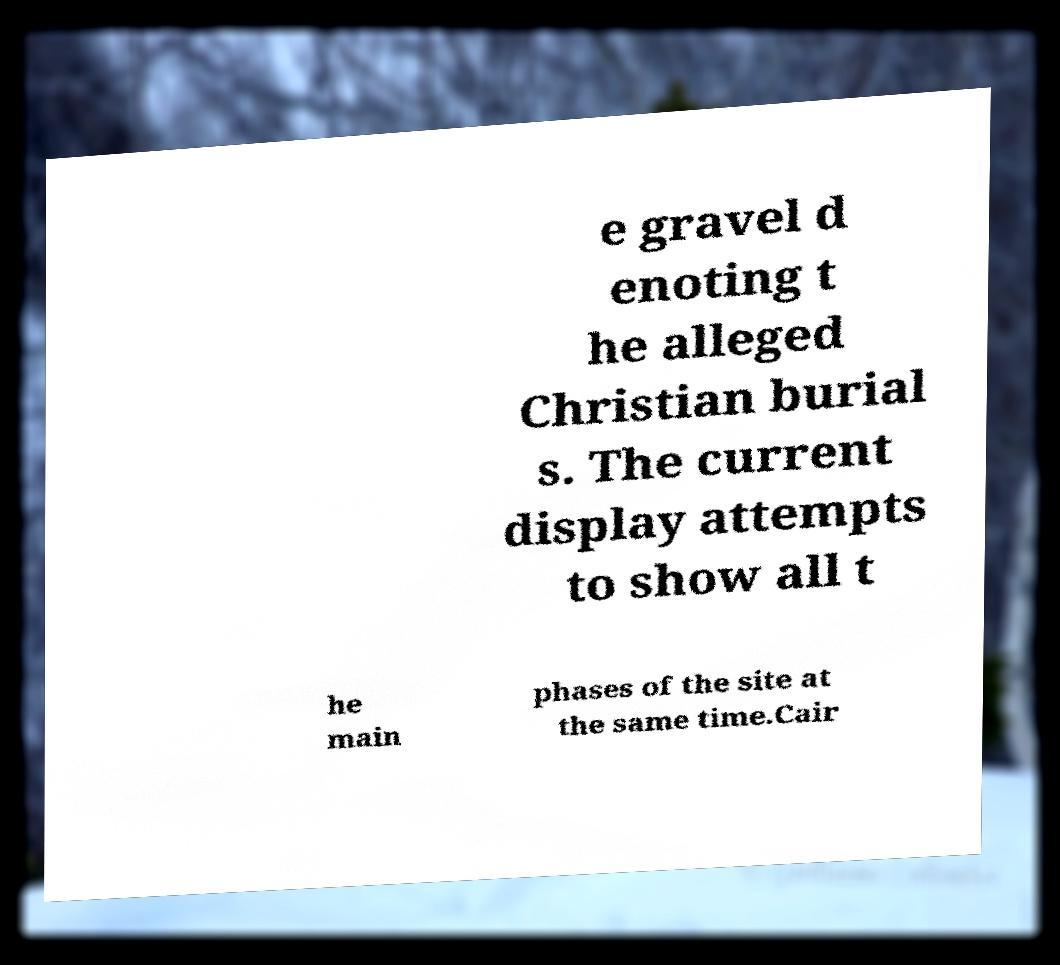Please identify and transcribe the text found in this image. e gravel d enoting t he alleged Christian burial s. The current display attempts to show all t he main phases of the site at the same time.Cair 